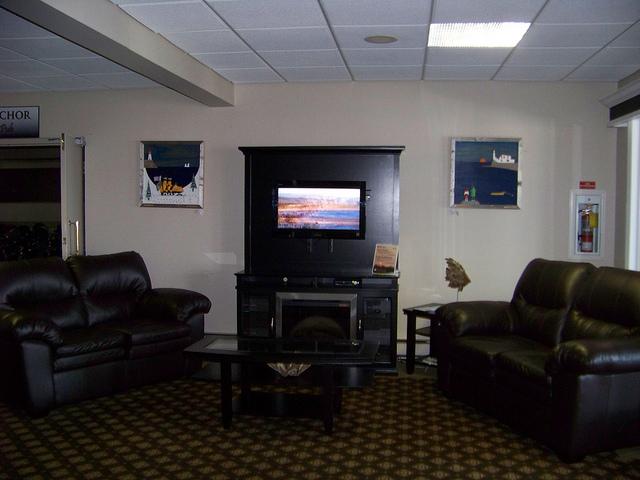How many love seat's is in the room?
Write a very short answer. 2. Is the fireplace burning wood?
Answer briefly. No. What color is the couch?
Give a very brief answer. Black. What color is this table?
Write a very short answer. Black. What is the table made of?
Give a very brief answer. Wood. Who is in the room?
Concise answer only. No one. 